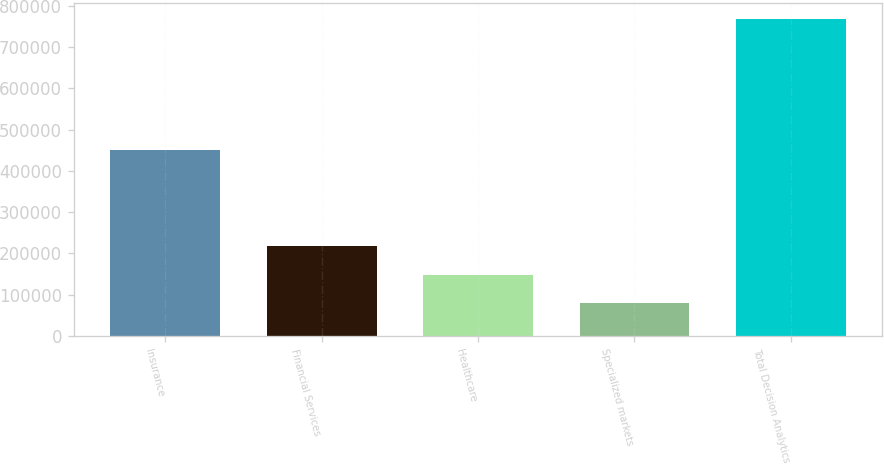Convert chart. <chart><loc_0><loc_0><loc_500><loc_500><bar_chart><fcel>Insurance<fcel>Financial Services<fcel>Healthcare<fcel>Specialized markets<fcel>Total Decision Analytics<nl><fcel>451216<fcel>216767<fcel>147803<fcel>78839<fcel>768479<nl></chart> 